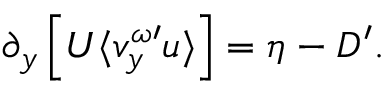<formula> <loc_0><loc_0><loc_500><loc_500>\partial _ { y } \left [ U \langle v _ { y } ^ { \omega \prime } u \rangle \right ] = \eta - D ^ { \prime } .</formula> 